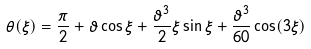<formula> <loc_0><loc_0><loc_500><loc_500>\theta ( \xi ) = \frac { \pi } { 2 } + \vartheta \cos \xi + \frac { \vartheta ^ { 3 } } { 2 } \xi \sin \xi + \frac { \vartheta ^ { 3 } } { 6 0 } \cos ( 3 \xi )</formula> 